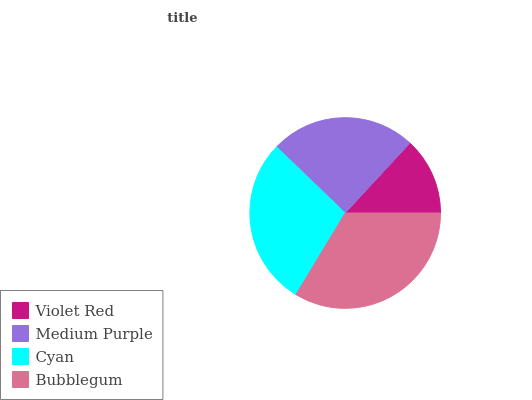Is Violet Red the minimum?
Answer yes or no. Yes. Is Bubblegum the maximum?
Answer yes or no. Yes. Is Medium Purple the minimum?
Answer yes or no. No. Is Medium Purple the maximum?
Answer yes or no. No. Is Medium Purple greater than Violet Red?
Answer yes or no. Yes. Is Violet Red less than Medium Purple?
Answer yes or no. Yes. Is Violet Red greater than Medium Purple?
Answer yes or no. No. Is Medium Purple less than Violet Red?
Answer yes or no. No. Is Cyan the high median?
Answer yes or no. Yes. Is Medium Purple the low median?
Answer yes or no. Yes. Is Bubblegum the high median?
Answer yes or no. No. Is Violet Red the low median?
Answer yes or no. No. 